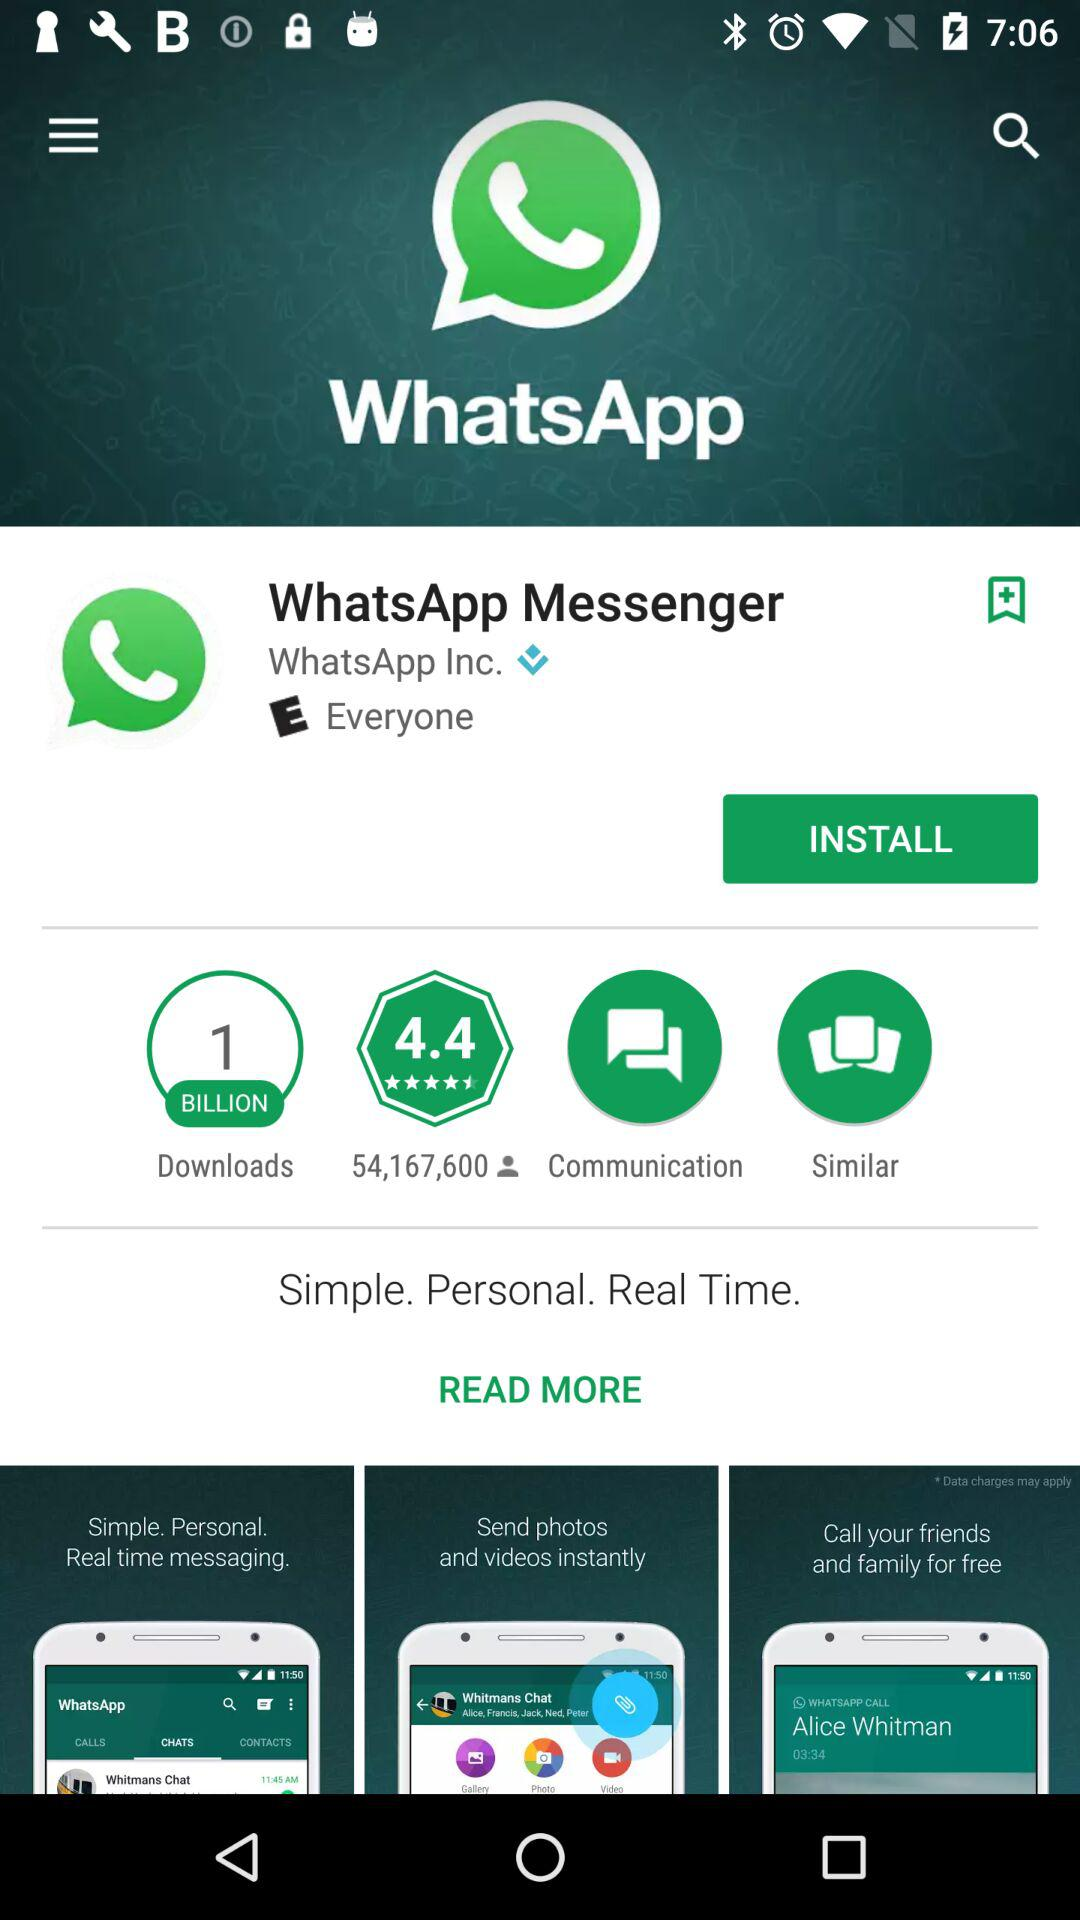How many people download WhatsApp? WhatsApp has been downloaded by 1 billion people. 